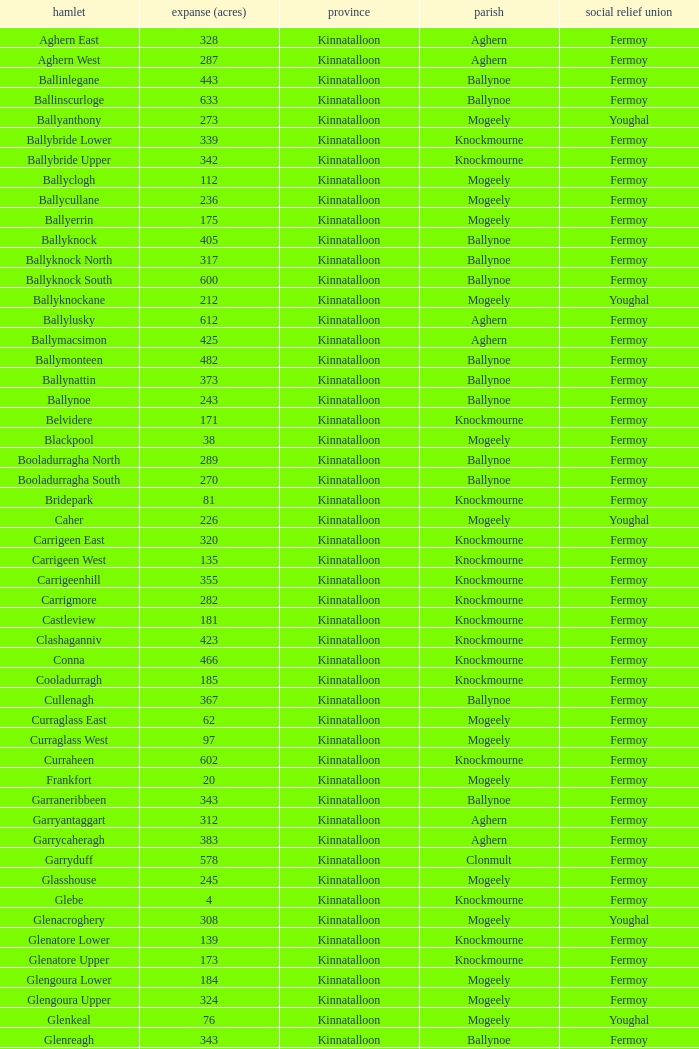Could you parse the entire table? {'header': ['hamlet', 'expanse (acres)', 'province', 'parish', 'social relief union'], 'rows': [['Aghern East', '328', 'Kinnatalloon', 'Aghern', 'Fermoy'], ['Aghern West', '287', 'Kinnatalloon', 'Aghern', 'Fermoy'], ['Ballinlegane', '443', 'Kinnatalloon', 'Ballynoe', 'Fermoy'], ['Ballinscurloge', '633', 'Kinnatalloon', 'Ballynoe', 'Fermoy'], ['Ballyanthony', '273', 'Kinnatalloon', 'Mogeely', 'Youghal'], ['Ballybride Lower', '339', 'Kinnatalloon', 'Knockmourne', 'Fermoy'], ['Ballybride Upper', '342', 'Kinnatalloon', 'Knockmourne', 'Fermoy'], ['Ballyclogh', '112', 'Kinnatalloon', 'Mogeely', 'Fermoy'], ['Ballycullane', '236', 'Kinnatalloon', 'Mogeely', 'Fermoy'], ['Ballyerrin', '175', 'Kinnatalloon', 'Mogeely', 'Fermoy'], ['Ballyknock', '405', 'Kinnatalloon', 'Ballynoe', 'Fermoy'], ['Ballyknock North', '317', 'Kinnatalloon', 'Ballynoe', 'Fermoy'], ['Ballyknock South', '600', 'Kinnatalloon', 'Ballynoe', 'Fermoy'], ['Ballyknockane', '212', 'Kinnatalloon', 'Mogeely', 'Youghal'], ['Ballylusky', '612', 'Kinnatalloon', 'Aghern', 'Fermoy'], ['Ballymacsimon', '425', 'Kinnatalloon', 'Aghern', 'Fermoy'], ['Ballymonteen', '482', 'Kinnatalloon', 'Ballynoe', 'Fermoy'], ['Ballynattin', '373', 'Kinnatalloon', 'Ballynoe', 'Fermoy'], ['Ballynoe', '243', 'Kinnatalloon', 'Ballynoe', 'Fermoy'], ['Belvidere', '171', 'Kinnatalloon', 'Knockmourne', 'Fermoy'], ['Blackpool', '38', 'Kinnatalloon', 'Mogeely', 'Fermoy'], ['Booladurragha North', '289', 'Kinnatalloon', 'Ballynoe', 'Fermoy'], ['Booladurragha South', '270', 'Kinnatalloon', 'Ballynoe', 'Fermoy'], ['Bridepark', '81', 'Kinnatalloon', 'Knockmourne', 'Fermoy'], ['Caher', '226', 'Kinnatalloon', 'Mogeely', 'Youghal'], ['Carrigeen East', '320', 'Kinnatalloon', 'Knockmourne', 'Fermoy'], ['Carrigeen West', '135', 'Kinnatalloon', 'Knockmourne', 'Fermoy'], ['Carrigeenhill', '355', 'Kinnatalloon', 'Knockmourne', 'Fermoy'], ['Carrigmore', '282', 'Kinnatalloon', 'Knockmourne', 'Fermoy'], ['Castleview', '181', 'Kinnatalloon', 'Knockmourne', 'Fermoy'], ['Clashaganniv', '423', 'Kinnatalloon', 'Knockmourne', 'Fermoy'], ['Conna', '466', 'Kinnatalloon', 'Knockmourne', 'Fermoy'], ['Cooladurragh', '185', 'Kinnatalloon', 'Knockmourne', 'Fermoy'], ['Cullenagh', '367', 'Kinnatalloon', 'Ballynoe', 'Fermoy'], ['Curraglass East', '62', 'Kinnatalloon', 'Mogeely', 'Fermoy'], ['Curraglass West', '97', 'Kinnatalloon', 'Mogeely', 'Fermoy'], ['Curraheen', '602', 'Kinnatalloon', 'Knockmourne', 'Fermoy'], ['Frankfort', '20', 'Kinnatalloon', 'Mogeely', 'Fermoy'], ['Garraneribbeen', '343', 'Kinnatalloon', 'Ballynoe', 'Fermoy'], ['Garryantaggart', '312', 'Kinnatalloon', 'Aghern', 'Fermoy'], ['Garrycaheragh', '383', 'Kinnatalloon', 'Aghern', 'Fermoy'], ['Garryduff', '578', 'Kinnatalloon', 'Clonmult', 'Fermoy'], ['Glasshouse', '245', 'Kinnatalloon', 'Mogeely', 'Fermoy'], ['Glebe', '4', 'Kinnatalloon', 'Knockmourne', 'Fermoy'], ['Glenacroghery', '308', 'Kinnatalloon', 'Mogeely', 'Youghal'], ['Glenatore Lower', '139', 'Kinnatalloon', 'Knockmourne', 'Fermoy'], ['Glenatore Upper', '173', 'Kinnatalloon', 'Knockmourne', 'Fermoy'], ['Glengoura Lower', '184', 'Kinnatalloon', 'Mogeely', 'Fermoy'], ['Glengoura Upper', '324', 'Kinnatalloon', 'Mogeely', 'Fermoy'], ['Glenkeal', '76', 'Kinnatalloon', 'Mogeely', 'Youghal'], ['Glenreagh', '343', 'Kinnatalloon', 'Ballynoe', 'Fermoy'], ['Glentane', '274', 'Kinnatalloon', 'Ballynoe', 'Fermoy'], ['Glentrasna', '284', 'Kinnatalloon', 'Aghern', 'Fermoy'], ['Glentrasna North', '219', 'Kinnatalloon', 'Aghern', 'Fermoy'], ['Glentrasna South', '220', 'Kinnatalloon', 'Aghern', 'Fermoy'], ['Gortnafira', '78', 'Kinnatalloon', 'Mogeely', 'Fermoy'], ['Inchyallagh', '8', 'Kinnatalloon', 'Mogeely', 'Fermoy'], ['Kilclare Lower', '109', 'Kinnatalloon', 'Knockmourne', 'Fermoy'], ['Kilclare Upper', '493', 'Kinnatalloon', 'Knockmourne', 'Fermoy'], ['Kilcronat', '516', 'Kinnatalloon', 'Mogeely', 'Youghal'], ['Kilcronatmountain', '385', 'Kinnatalloon', 'Mogeely', 'Youghal'], ['Killasseragh', '340', 'Kinnatalloon', 'Ballynoe', 'Fermoy'], ['Killavarilly', '372', 'Kinnatalloon', 'Knockmourne', 'Fermoy'], ['Kilmacow', '316', 'Kinnatalloon', 'Mogeely', 'Fermoy'], ['Kilnafurrery', '256', 'Kinnatalloon', 'Mogeely', 'Youghal'], ['Kilphillibeen', '535', 'Kinnatalloon', 'Ballynoe', 'Fermoy'], ['Knockacool', '404', 'Kinnatalloon', 'Mogeely', 'Youghal'], ['Knockakeo', '296', 'Kinnatalloon', 'Ballynoe', 'Fermoy'], ['Knockanarrig', '215', 'Kinnatalloon', 'Mogeely', 'Youghal'], ['Knockastickane', '164', 'Kinnatalloon', 'Knockmourne', 'Fermoy'], ['Knocknagapple', '293', 'Kinnatalloon', 'Aghern', 'Fermoy'], ['Lackbrack', '84', 'Kinnatalloon', 'Mogeely', 'Fermoy'], ['Lacken', '262', 'Kinnatalloon', 'Mogeely', 'Youghal'], ['Lackenbehy', '101', 'Kinnatalloon', 'Mogeely', 'Fermoy'], ['Limekilnclose', '41', 'Kinnatalloon', 'Mogeely', 'Lismore'], ['Lisnabrin Lower', '114', 'Kinnatalloon', 'Mogeely', 'Fermoy'], ['Lisnabrin North', '217', 'Kinnatalloon', 'Mogeely', 'Fermoy'], ['Lisnabrin South', '180', 'Kinnatalloon', 'Mogeely', 'Fermoy'], ['Lisnabrinlodge', '28', 'Kinnatalloon', 'Mogeely', 'Fermoy'], ['Littlegrace', '50', 'Kinnatalloon', 'Knockmourne', 'Lismore'], ['Longueville North', '355', 'Kinnatalloon', 'Ballynoe', 'Fermoy'], ['Longueville South', '271', 'Kinnatalloon', 'Ballynoe', 'Fermoy'], ['Lyre', '160', 'Kinnatalloon', 'Mogeely', 'Youghal'], ['Lyre Mountain', '360', 'Kinnatalloon', 'Mogeely', 'Youghal'], ['Mogeely Lower', '304', 'Kinnatalloon', 'Mogeely', 'Fermoy'], ['Mogeely Upper', '247', 'Kinnatalloon', 'Mogeely', 'Fermoy'], ['Monagown', '491', 'Kinnatalloon', 'Knockmourne', 'Fermoy'], ['Monaloo', '458', 'Kinnatalloon', 'Mogeely', 'Youghal'], ['Mountprospect', '102', 'Kinnatalloon', 'Mogeely', 'Fermoy'], ['Park', '119', 'Kinnatalloon', 'Aghern', 'Fermoy'], ['Poundfields', '15', 'Kinnatalloon', 'Mogeely', 'Fermoy'], ['Rathdrum', '336', 'Kinnatalloon', 'Ballynoe', 'Fermoy'], ['Rathdrum', '339', 'Kinnatalloon', 'Britway', 'Fermoy'], ['Reanduff', '318', 'Kinnatalloon', 'Mogeely', 'Youghal'], ['Rearour North', '208', 'Kinnatalloon', 'Mogeely', 'Youghal'], ['Rearour South', '223', 'Kinnatalloon', 'Mogeely', 'Youghal'], ['Rosybower', '105', 'Kinnatalloon', 'Mogeely', 'Fermoy'], ['Sandyhill', '263', 'Kinnatalloon', 'Mogeely', 'Youghal'], ['Shanaboola', '190', 'Kinnatalloon', 'Ballynoe', 'Fermoy'], ['Shanakill Lower', '244', 'Kinnatalloon', 'Mogeely', 'Fermoy'], ['Shanakill Upper', '244', 'Kinnatalloon', 'Mogeely', 'Fermoy'], ['Slieveadoctor', '260', 'Kinnatalloon', 'Mogeely', 'Fermoy'], ['Templevally', '330', 'Kinnatalloon', 'Mogeely', 'Fermoy'], ['Vinepark', '7', 'Kinnatalloon', 'Mogeely', 'Fermoy']]} Name the civil parish for garryduff Clonmult. 